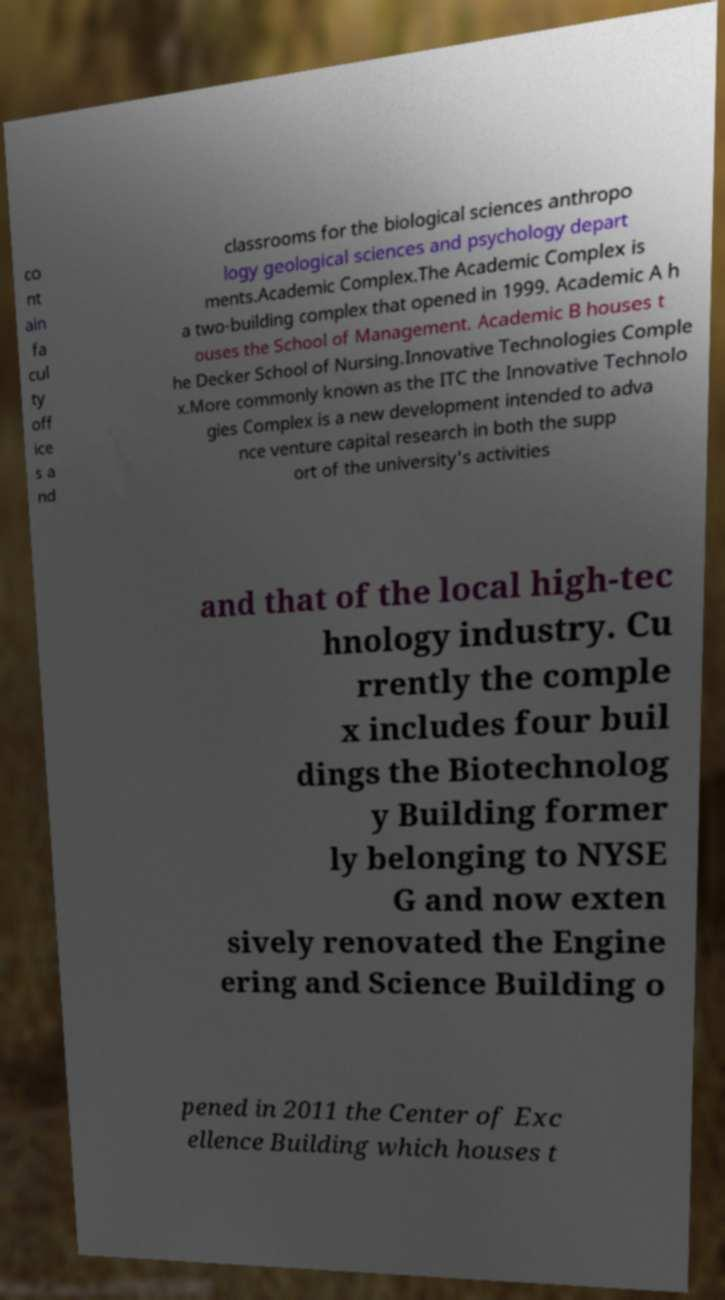Could you extract and type out the text from this image? co nt ain fa cul ty off ice s a nd classrooms for the biological sciences anthropo logy geological sciences and psychology depart ments.Academic Complex.The Academic Complex is a two-building complex that opened in 1999. Academic A h ouses the School of Management. Academic B houses t he Decker School of Nursing.Innovative Technologies Comple x.More commonly known as the ITC the Innovative Technolo gies Complex is a new development intended to adva nce venture capital research in both the supp ort of the university's activities and that of the local high-tec hnology industry. Cu rrently the comple x includes four buil dings the Biotechnolog y Building former ly belonging to NYSE G and now exten sively renovated the Engine ering and Science Building o pened in 2011 the Center of Exc ellence Building which houses t 